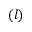Convert formula to latex. <formula><loc_0><loc_0><loc_500><loc_500>( l )</formula> 